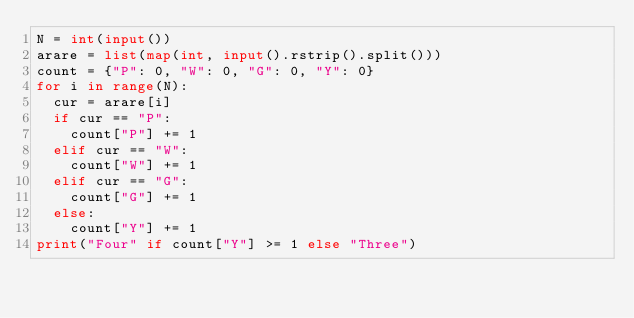Convert code to text. <code><loc_0><loc_0><loc_500><loc_500><_Python_>N = int(input())
arare = list(map(int, input().rstrip().split()))
count = {"P": 0, "W": 0, "G": 0, "Y": 0}
for i in range(N):
  cur = arare[i]
  if cur == "P":
    count["P"] += 1
  elif cur == "W":
    count["W"] += 1
  elif cur == "G":
    count["G"] += 1
  else:
    count["Y"] += 1
print("Four" if count["Y"] >= 1 else "Three")</code> 